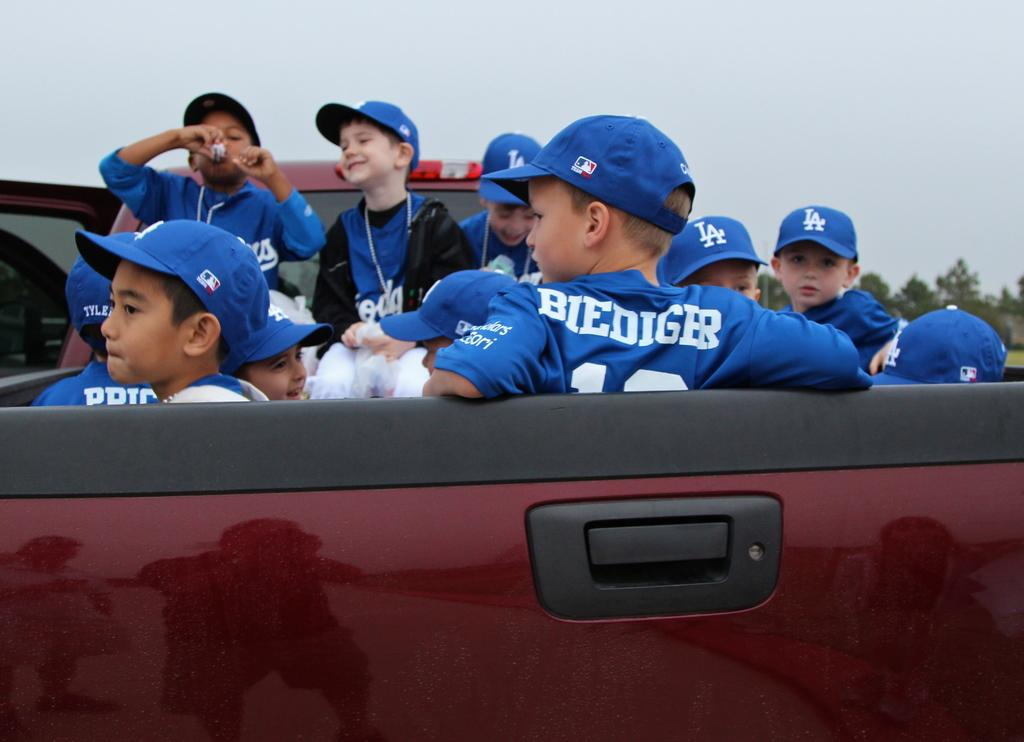<image>
Render a clear and concise summary of the photo. Boys in blue and white LA baseball uniforms are riding in the back of a maroon pickup truck. 